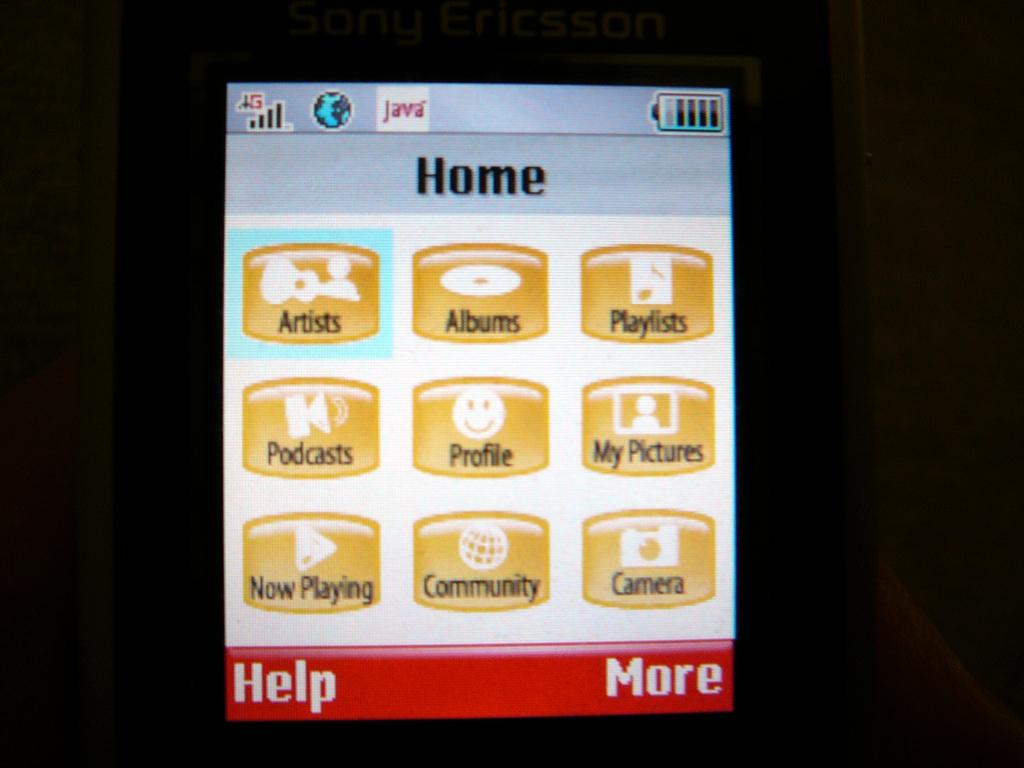Provide a one-sentence caption for the provided image. The sipaly screen of a cellphone showing options for music playlists, podcasts and other media. 